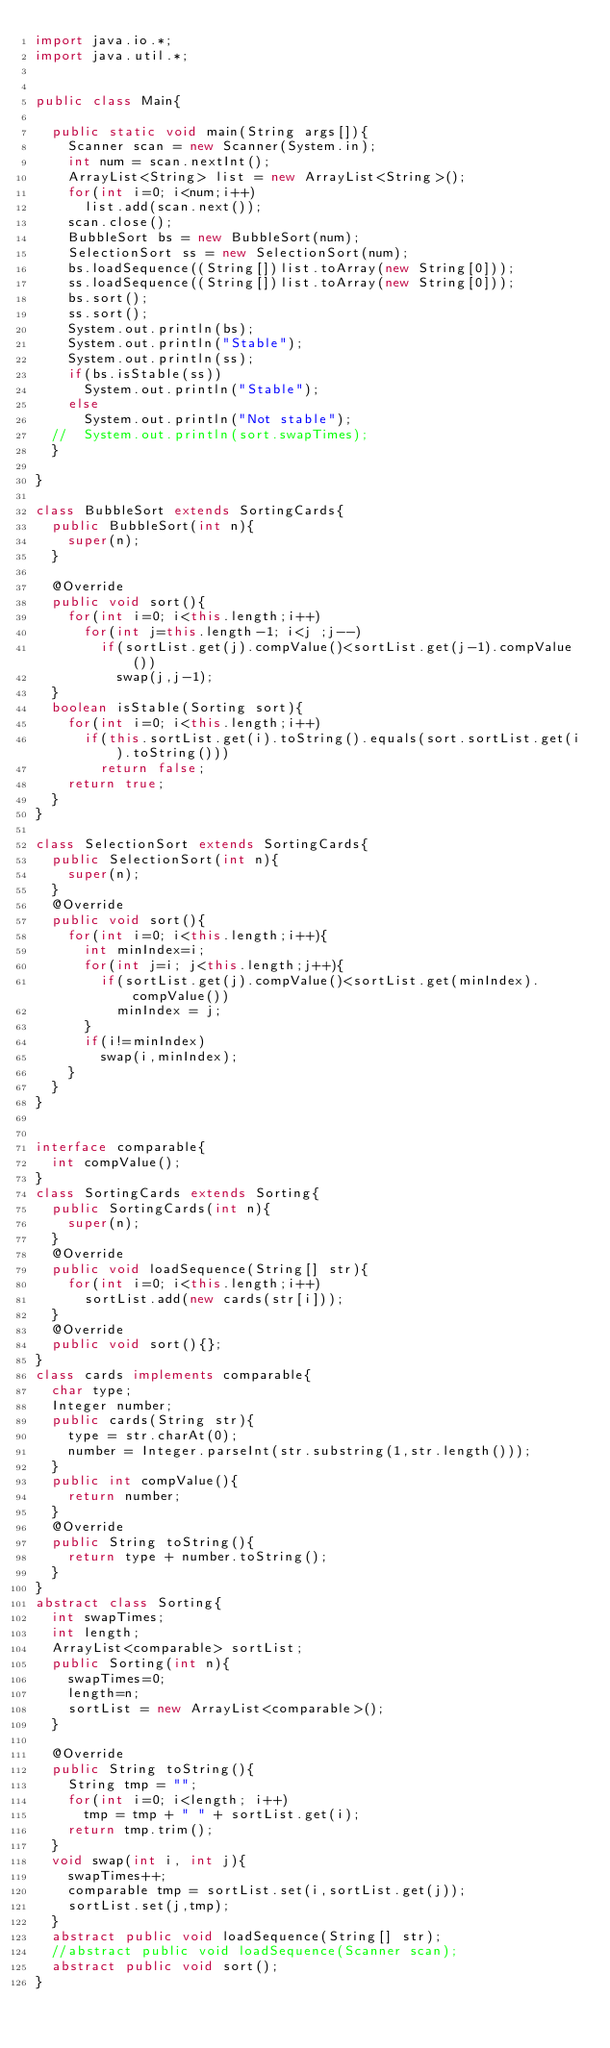<code> <loc_0><loc_0><loc_500><loc_500><_Java_>import java.io.*;
import java.util.*;


public class Main{ 

	public static void main(String args[]){
		Scanner scan = new Scanner(System.in);
		int num = scan.nextInt();
		ArrayList<String> list = new ArrayList<String>();
		for(int i=0; i<num;i++)
			list.add(scan.next());
		scan.close();
		BubbleSort bs = new BubbleSort(num);
		SelectionSort ss = new SelectionSort(num);
		bs.loadSequence((String[])list.toArray(new String[0]));
		ss.loadSequence((String[])list.toArray(new String[0]));
		bs.sort();
		ss.sort();
		System.out.println(bs);
		System.out.println("Stable");
		System.out.println(ss);
		if(bs.isStable(ss))
			System.out.println("Stable");
		else
			System.out.println("Not stable");
	//	System.out.println(sort.swapTimes);
	}

}

class BubbleSort extends SortingCards{
	public BubbleSort(int n){
		super(n);
	}

	@Override
	public void sort(){
		for(int i=0; i<this.length;i++)
			for(int j=this.length-1; i<j ;j--)
				if(sortList.get(j).compValue()<sortList.get(j-1).compValue())
					swap(j,j-1);
	}
	boolean isStable(Sorting sort){
		for(int i=0; i<this.length;i++)
			if(this.sortList.get(i).toString().equals(sort.sortList.get(i).toString()))
				return false;
		return true;
	}	
}

class SelectionSort extends SortingCards{
	public SelectionSort(int n){
		super(n);
	}
	@Override
	public void sort(){
		for(int i=0; i<this.length;i++){
			int minIndex=i;
			for(int j=i; j<this.length;j++){
				if(sortList.get(j).compValue()<sortList.get(minIndex).compValue())
					minIndex = j;
			}
			if(i!=minIndex)
				swap(i,minIndex);
		}
	}	
}


interface comparable{
	int compValue();
}
class SortingCards extends Sorting{
	public SortingCards(int n){
		super(n);
	}
	@Override
	public void loadSequence(String[] str){
		for(int i=0; i<this.length;i++)
			sortList.add(new cards(str[i]));
	}
	@Override
	public void sort(){};
}
class cards implements comparable{
	char type;
	Integer number;
	public cards(String str){
		type = str.charAt(0);
		number = Integer.parseInt(str.substring(1,str.length()));		
	}
	public int compValue(){
		return number;
	}
	@Override
	public String toString(){
		return type + number.toString();
	}
}
abstract class Sorting{
	int swapTimes;
	int length;
	ArrayList<comparable> sortList;
	public Sorting(int n){
		swapTimes=0;
		length=n;
		sortList = new ArrayList<comparable>();
	}
	
	@Override
	public String toString(){
		String tmp = "";
		for(int i=0; i<length; i++)
			tmp = tmp + " " + sortList.get(i);
		return tmp.trim();
	}
	void swap(int i, int j){
		swapTimes++;
		comparable tmp = sortList.set(i,sortList.get(j));
		sortList.set(j,tmp);
	}
	abstract public void loadSequence(String[] str);
	//abstract public void loadSequence(Scanner scan);
	abstract public void sort();
}</code> 